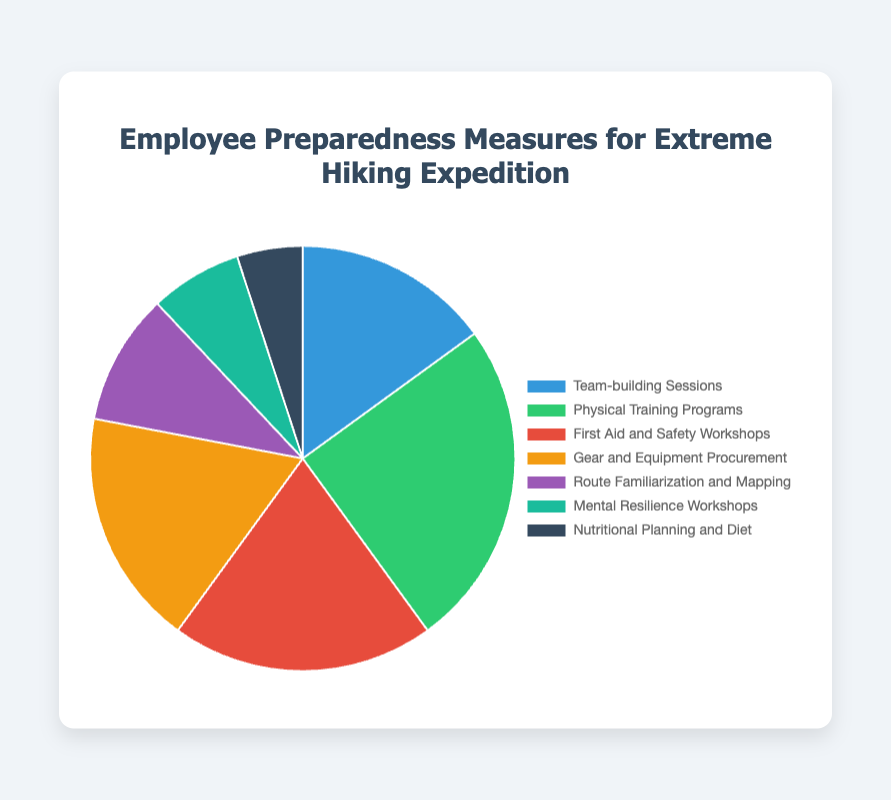Which preparedness measure has the highest percentage? The largest segment in the pie chart represents the preparedness measure with the highest percentage. The "Physical Training Programs" segment is the largest.
Answer: Physical Training Programs What is the combined percentage of "Gear and Equipment Procurement" and "Route Familiarization and Mapping"? Add the percentages of "Gear and Equipment Procurement" (18%) and "Route Familiarization and Mapping" (10%). 18% + 10% = 28%
Answer: 28% How does the percentage of "Mental Resilience Workshops" compare to that of "First Aid and Safety Workshops"? Compare the percentages of "Mental Resilience Workshops" (7%) and "First Aid and Safety Workshops" (20%). 7% is less than 20%.
Answer: Less Which two measures together make up exactly one-third (33.33%) of the total preparedness? The measures whose percentages sum up to roughly one-third (33.33%) are "First Aid and Safety Workshops" (20%) and "Gear and Equipment Procurement" (18%). 20% + 18% = 38%, which is closest to one-third.
Answer: First Aid and Safety Workshops and Gear and Equipment Procurement What is the difference in percentage between the highest and lowest measures? Subtract the percentage of the lowest measure "Nutritional Planning and Diet" (5%) from the highest "Physical Training Programs" (25%). 25% - 5% = 20%
Answer: 20% By how much is the percentage of "Team-building Sessions" greater than that of "Nutritional Planning and Diet"? Subtract the percentage of "Nutritional Planning and Diet" (5%) from "Team-building Sessions" (15%). 15% - 5% = 10%
Answer: 10% What is the average percentage of all preparedness measures? Sum all percentages and divide by the number of measures. Sum = 15% + 25% + 20% + 18% + 10% + 7% + 5% = 100%. Average = 100% / 7 ≈ 14.29%
Answer: 14.29% If you combine "Mental Resilience Workshops" and "Nutritional Planning and Diet", what fraction of the total do they represent (in %)? Add the percentages of "Mental Resilience Workshops" (7%) and "Nutritional Planning and Diet" (5%). 7% + 5% = 12%
Answer: 12% 